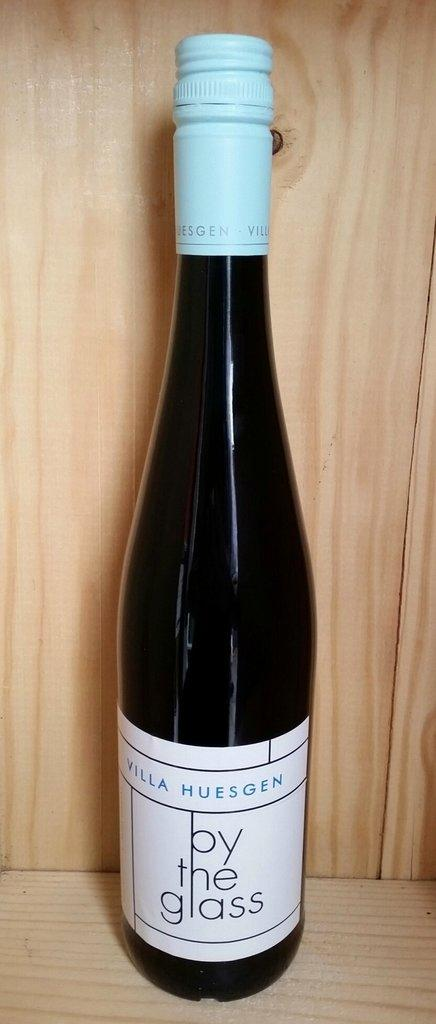Provide a one-sentence caption for the provided image. A bottle o wine with by the glass on the label. 